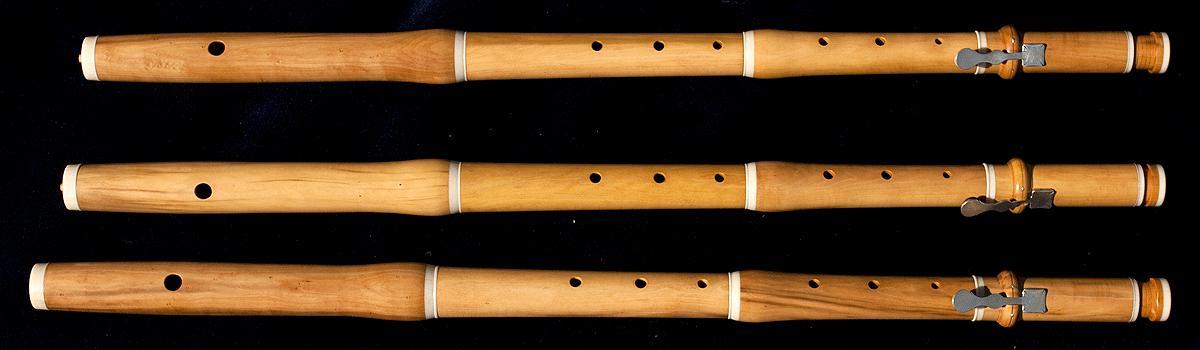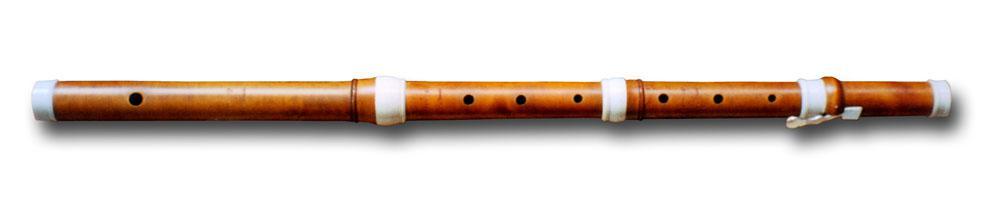The first image is the image on the left, the second image is the image on the right. Assess this claim about the two images: "There are two musical instruments.". Correct or not? Answer yes or no. No. The first image is the image on the left, the second image is the image on the right. Given the left and right images, does the statement "The left and right images do not contain the same number of items, but the combined images include at least four items of the same color." hold true? Answer yes or no. Yes. 